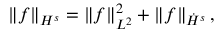<formula> <loc_0><loc_0><loc_500><loc_500>\left \| f \right \| _ { H ^ { s } } = \left \| f \right \| _ { L ^ { 2 } } ^ { 2 } + \left \| f \right \| _ { \dot { H } ^ { s } } ,</formula> 